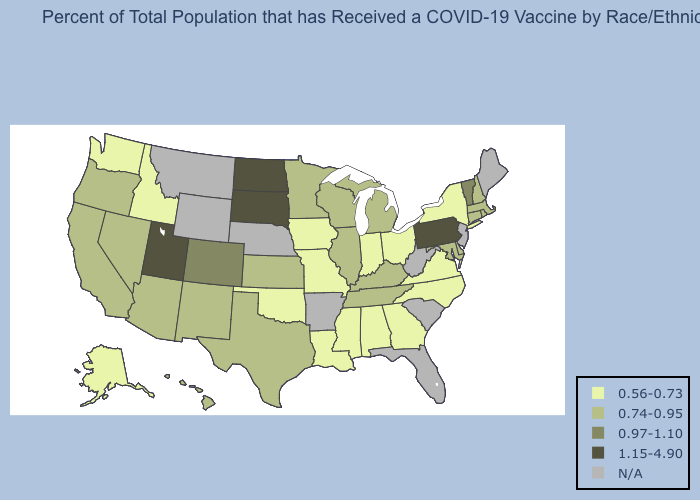What is the lowest value in states that border Rhode Island?
Keep it brief. 0.74-0.95. What is the lowest value in the West?
Be succinct. 0.56-0.73. Name the states that have a value in the range N/A?
Answer briefly. Arkansas, Florida, Maine, Montana, Nebraska, New Jersey, South Carolina, West Virginia, Wyoming. Name the states that have a value in the range 0.97-1.10?
Write a very short answer. Colorado, Vermont. Name the states that have a value in the range N/A?
Give a very brief answer. Arkansas, Florida, Maine, Montana, Nebraska, New Jersey, South Carolina, West Virginia, Wyoming. Among the states that border Nebraska , which have the lowest value?
Short answer required. Iowa, Missouri. Does Texas have the highest value in the South?
Short answer required. Yes. Does California have the lowest value in the USA?
Give a very brief answer. No. What is the highest value in states that border Delaware?
Short answer required. 1.15-4.90. Among the states that border Georgia , does Alabama have the highest value?
Give a very brief answer. No. What is the value of Virginia?
Be succinct. 0.56-0.73. What is the value of Georgia?
Concise answer only. 0.56-0.73. How many symbols are there in the legend?
Write a very short answer. 5. What is the value of Arkansas?
Quick response, please. N/A. 